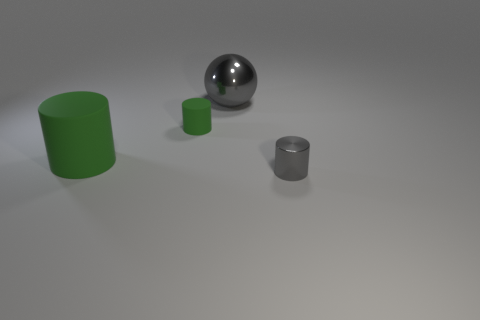Subtract all small cylinders. How many cylinders are left? 1 Subtract all gray cylinders. How many cylinders are left? 2 Subtract 1 balls. How many balls are left? 0 Add 2 big purple shiny blocks. How many objects exist? 6 Subtract all cylinders. How many objects are left? 1 Subtract 0 yellow cylinders. How many objects are left? 4 Subtract all brown cylinders. Subtract all brown blocks. How many cylinders are left? 3 Subtract all gray balls. How many yellow cylinders are left? 0 Subtract all tiny red metal things. Subtract all balls. How many objects are left? 3 Add 2 big gray balls. How many big gray balls are left? 3 